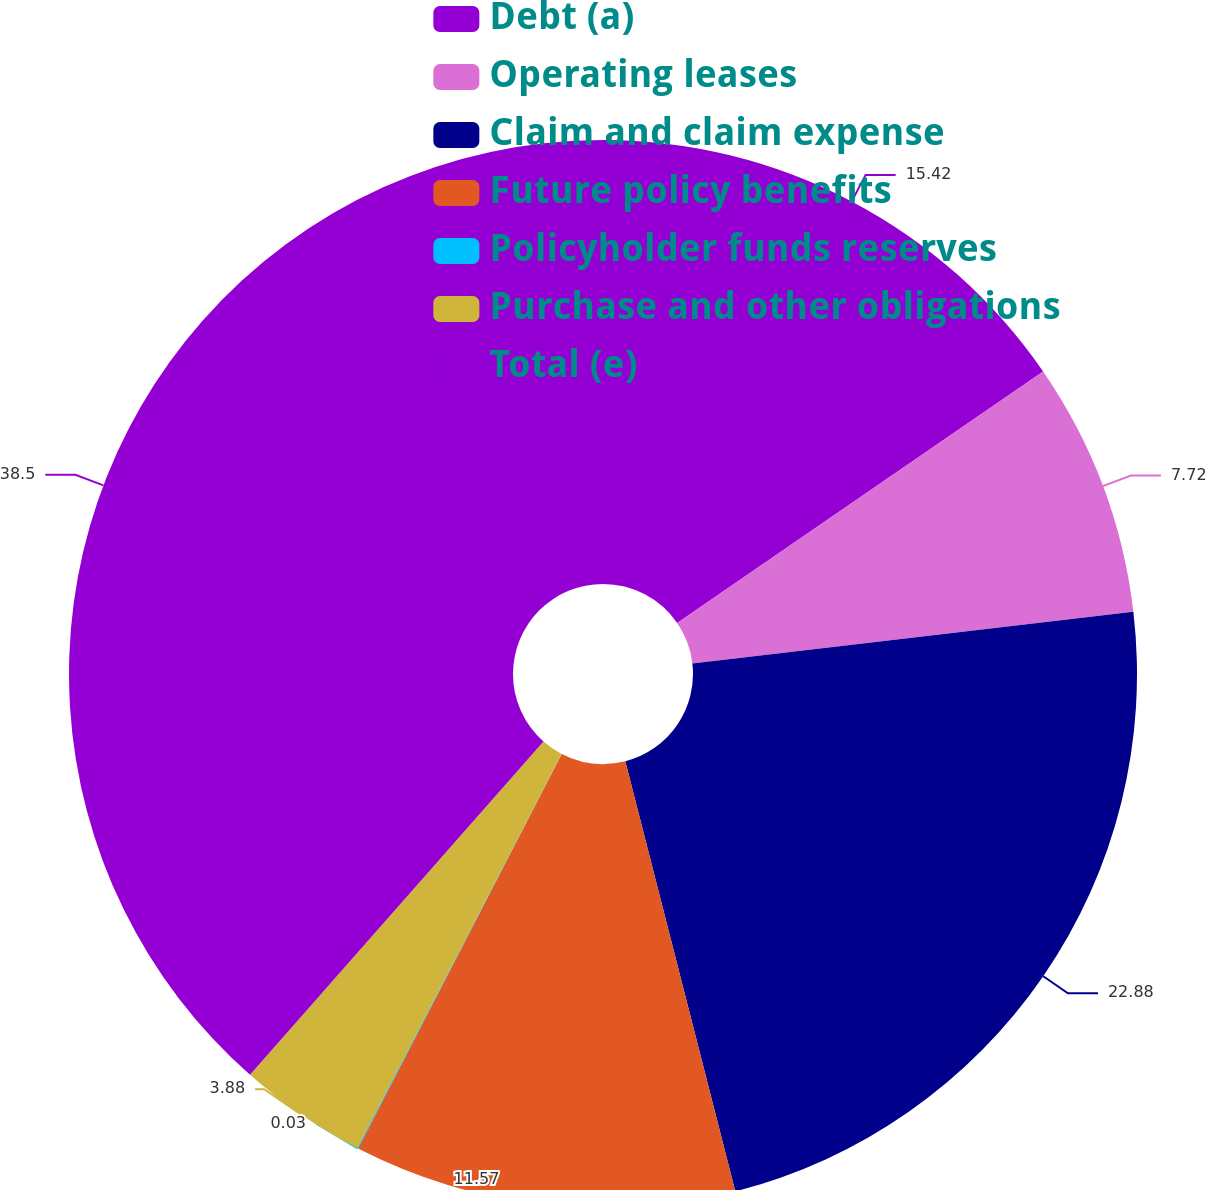Convert chart to OTSL. <chart><loc_0><loc_0><loc_500><loc_500><pie_chart><fcel>Debt (a)<fcel>Operating leases<fcel>Claim and claim expense<fcel>Future policy benefits<fcel>Policyholder funds reserves<fcel>Purchase and other obligations<fcel>Total (e)<nl><fcel>15.42%<fcel>7.72%<fcel>22.88%<fcel>11.57%<fcel>0.03%<fcel>3.88%<fcel>38.51%<nl></chart> 